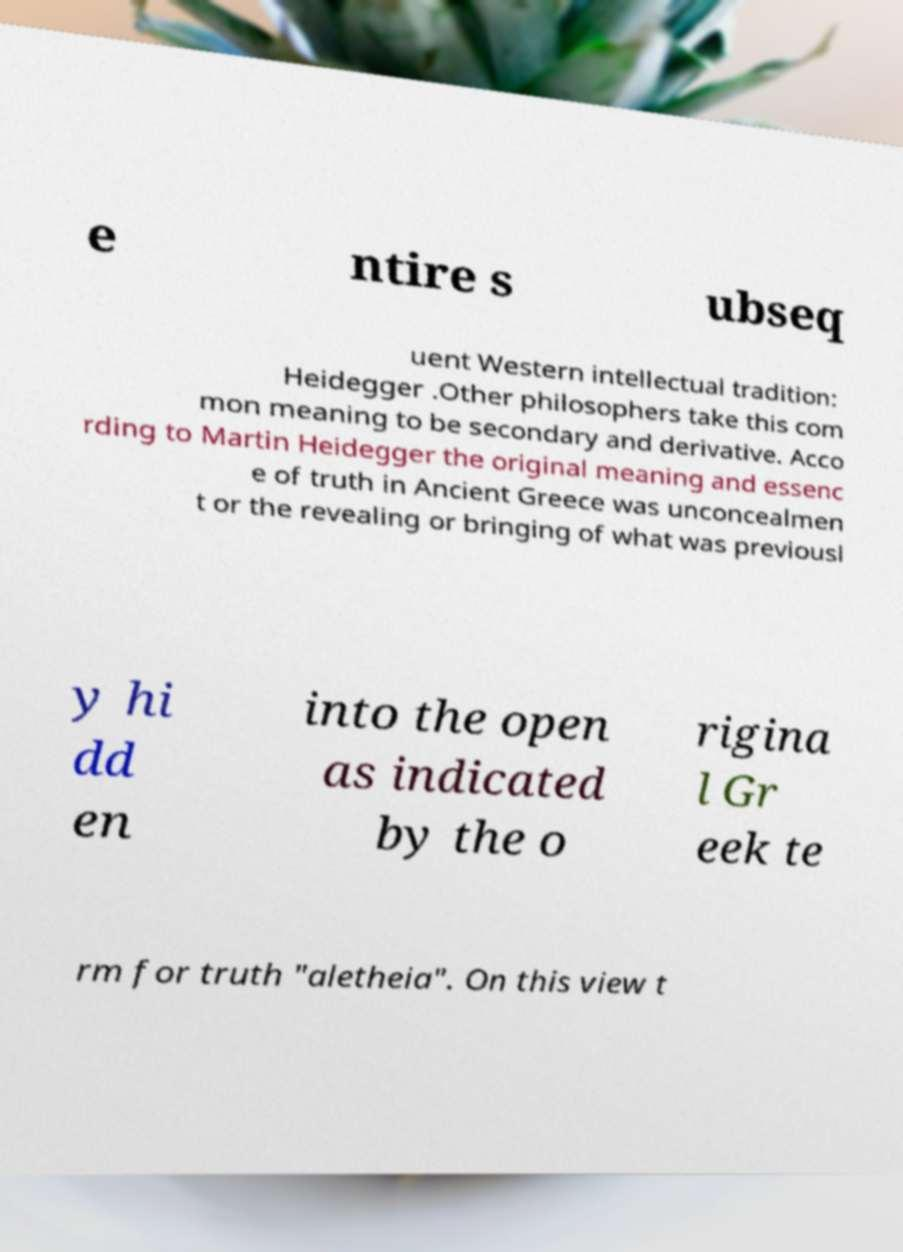Please read and relay the text visible in this image. What does it say? e ntire s ubseq uent Western intellectual tradition: Heidegger .Other philosophers take this com mon meaning to be secondary and derivative. Acco rding to Martin Heidegger the original meaning and essenc e of truth in Ancient Greece was unconcealmen t or the revealing or bringing of what was previousl y hi dd en into the open as indicated by the o rigina l Gr eek te rm for truth "aletheia". On this view t 